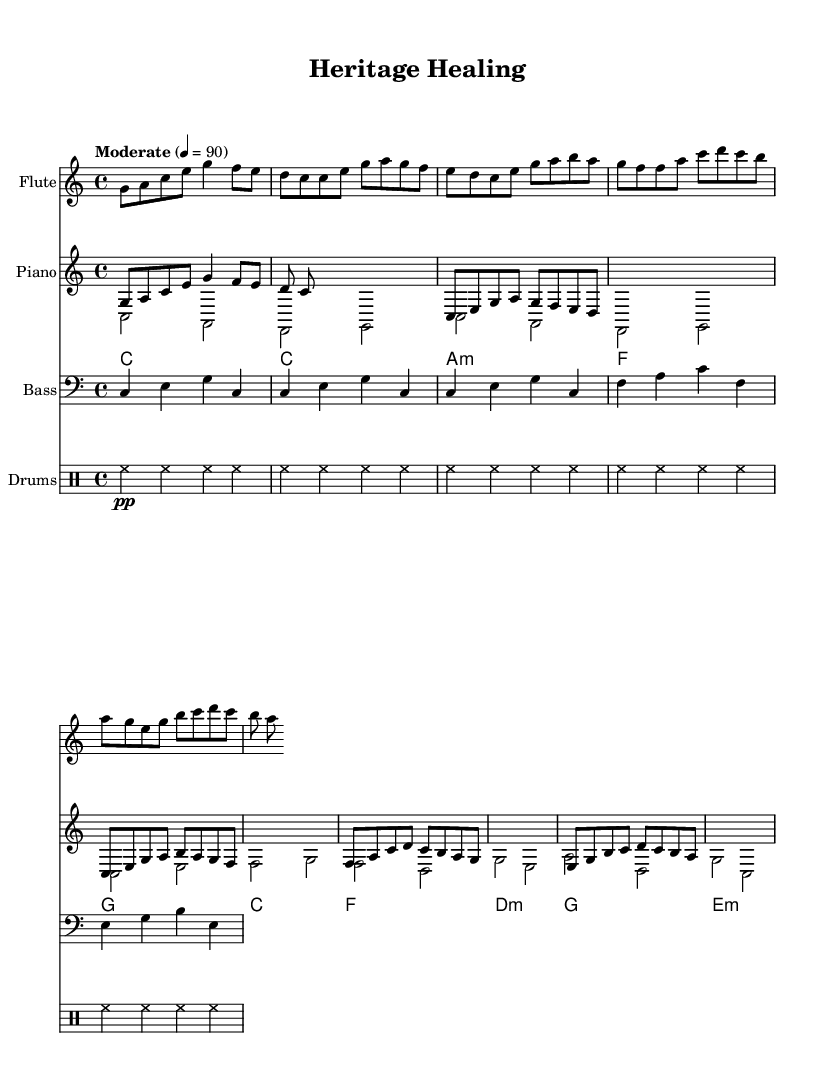What is the key signature of this music? The key signature is indicated at the beginning of the score, which shows that there are no sharps or flats. This confirms that the music is in C major.
Answer: C major What is the time signature of this music? The time signature is found at the start of the piece and is written as 4/4, indicating that each measure contains four beats and the quarter note gets one beat.
Answer: 4/4 What is the tempo marking for this piece? The tempo marking is included along with the score and is stated as "Moderate" with a metronome marking of 4 = 90, indicating a moderate pace.
Answer: Moderate, 90 How many measures are there in the music? The total number of measures can be counted from the beginning to the end of the score. In this case, there are a total of 10 measures.
Answer: 10 What instruments are featured in this sheet music? The instruments are listed at the beginning of the score, showing a flute, piano, guitar, bass, and drums.
Answer: Flute, piano, guitar, bass, drums What type of jazz does this piece represent? The unique blend of elements from the patient's heritage suggests that it embodies cultural fusion jazz, combining various musical influences for comfort and familiarity.
Answer: Cultural fusion jazz How is the rhythm pattern structured in the piece? The rhythm pattern can be determined by examining the drum section, which indicates a consistent and repetitive pattern throughout, offering a steady pulse for the ensemble.
Answer: Repetitive pattern 